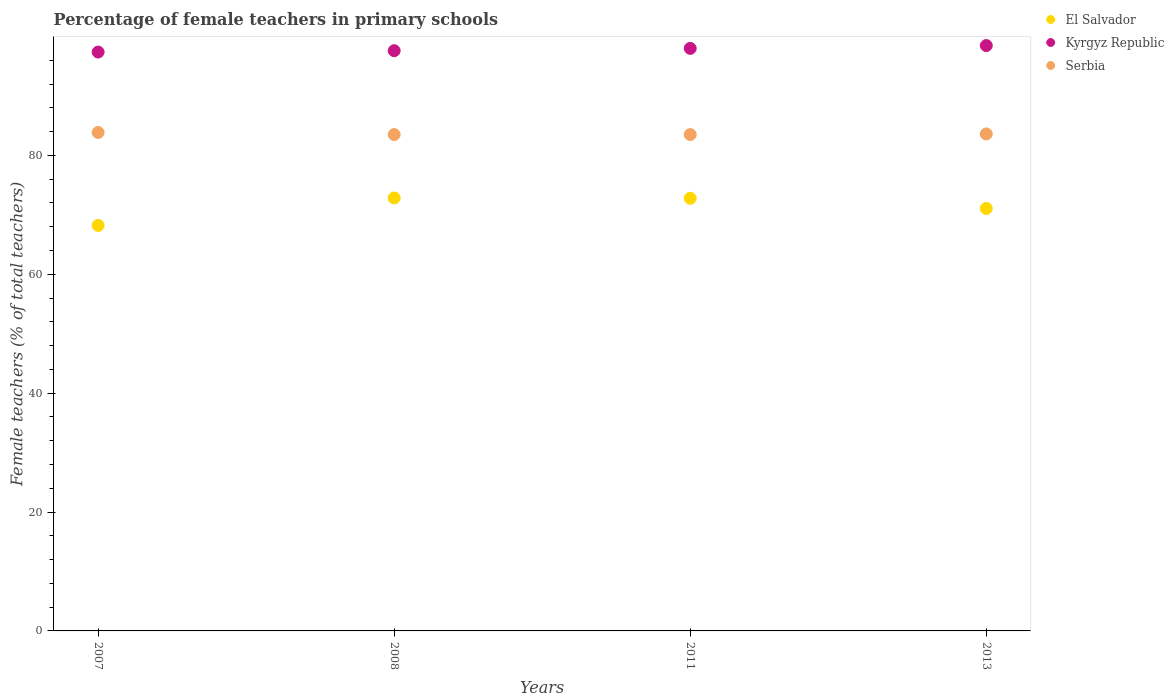What is the percentage of female teachers in Serbia in 2008?
Provide a succinct answer. 83.51. Across all years, what is the maximum percentage of female teachers in El Salvador?
Offer a terse response. 72.84. Across all years, what is the minimum percentage of female teachers in Serbia?
Provide a short and direct response. 83.5. In which year was the percentage of female teachers in Kyrgyz Republic maximum?
Make the answer very short. 2013. What is the total percentage of female teachers in El Salvador in the graph?
Make the answer very short. 284.91. What is the difference between the percentage of female teachers in Serbia in 2007 and that in 2013?
Ensure brevity in your answer.  0.24. What is the difference between the percentage of female teachers in El Salvador in 2013 and the percentage of female teachers in Serbia in 2007?
Keep it short and to the point. -12.78. What is the average percentage of female teachers in El Salvador per year?
Make the answer very short. 71.23. In the year 2007, what is the difference between the percentage of female teachers in Serbia and percentage of female teachers in El Salvador?
Offer a terse response. 15.63. In how many years, is the percentage of female teachers in El Salvador greater than 4 %?
Provide a succinct answer. 4. What is the ratio of the percentage of female teachers in El Salvador in 2007 to that in 2013?
Your answer should be very brief. 0.96. Is the difference between the percentage of female teachers in Serbia in 2011 and 2013 greater than the difference between the percentage of female teachers in El Salvador in 2011 and 2013?
Provide a short and direct response. No. What is the difference between the highest and the second highest percentage of female teachers in Serbia?
Your answer should be very brief. 0.24. What is the difference between the highest and the lowest percentage of female teachers in Serbia?
Provide a succinct answer. 0.35. In how many years, is the percentage of female teachers in Kyrgyz Republic greater than the average percentage of female teachers in Kyrgyz Republic taken over all years?
Offer a very short reply. 2. Is the sum of the percentage of female teachers in Serbia in 2007 and 2011 greater than the maximum percentage of female teachers in Kyrgyz Republic across all years?
Give a very brief answer. Yes. Is it the case that in every year, the sum of the percentage of female teachers in Serbia and percentage of female teachers in Kyrgyz Republic  is greater than the percentage of female teachers in El Salvador?
Your answer should be very brief. Yes. Is the percentage of female teachers in Serbia strictly less than the percentage of female teachers in El Salvador over the years?
Offer a very short reply. No. How many dotlines are there?
Ensure brevity in your answer.  3. What is the difference between two consecutive major ticks on the Y-axis?
Offer a very short reply. 20. Does the graph contain any zero values?
Your answer should be compact. No. How many legend labels are there?
Provide a succinct answer. 3. What is the title of the graph?
Give a very brief answer. Percentage of female teachers in primary schools. Does "Egypt, Arab Rep." appear as one of the legend labels in the graph?
Your answer should be very brief. No. What is the label or title of the Y-axis?
Ensure brevity in your answer.  Female teachers (% of total teachers). What is the Female teachers (% of total teachers) of El Salvador in 2007?
Provide a succinct answer. 68.22. What is the Female teachers (% of total teachers) of Kyrgyz Republic in 2007?
Offer a very short reply. 97.38. What is the Female teachers (% of total teachers) in Serbia in 2007?
Make the answer very short. 83.85. What is the Female teachers (% of total teachers) of El Salvador in 2008?
Make the answer very short. 72.84. What is the Female teachers (% of total teachers) of Kyrgyz Republic in 2008?
Offer a very short reply. 97.62. What is the Female teachers (% of total teachers) in Serbia in 2008?
Provide a short and direct response. 83.51. What is the Female teachers (% of total teachers) of El Salvador in 2011?
Provide a succinct answer. 72.78. What is the Female teachers (% of total teachers) in Kyrgyz Republic in 2011?
Ensure brevity in your answer.  98.01. What is the Female teachers (% of total teachers) of Serbia in 2011?
Offer a very short reply. 83.5. What is the Female teachers (% of total teachers) of El Salvador in 2013?
Provide a succinct answer. 71.07. What is the Female teachers (% of total teachers) in Kyrgyz Republic in 2013?
Your answer should be compact. 98.48. What is the Female teachers (% of total teachers) in Serbia in 2013?
Keep it short and to the point. 83.61. Across all years, what is the maximum Female teachers (% of total teachers) of El Salvador?
Your response must be concise. 72.84. Across all years, what is the maximum Female teachers (% of total teachers) of Kyrgyz Republic?
Your answer should be compact. 98.48. Across all years, what is the maximum Female teachers (% of total teachers) of Serbia?
Ensure brevity in your answer.  83.85. Across all years, what is the minimum Female teachers (% of total teachers) in El Salvador?
Ensure brevity in your answer.  68.22. Across all years, what is the minimum Female teachers (% of total teachers) in Kyrgyz Republic?
Offer a terse response. 97.38. Across all years, what is the minimum Female teachers (% of total teachers) of Serbia?
Keep it short and to the point. 83.5. What is the total Female teachers (% of total teachers) of El Salvador in the graph?
Your response must be concise. 284.91. What is the total Female teachers (% of total teachers) of Kyrgyz Republic in the graph?
Your answer should be very brief. 391.48. What is the total Female teachers (% of total teachers) in Serbia in the graph?
Give a very brief answer. 334.48. What is the difference between the Female teachers (% of total teachers) of El Salvador in 2007 and that in 2008?
Give a very brief answer. -4.62. What is the difference between the Female teachers (% of total teachers) of Kyrgyz Republic in 2007 and that in 2008?
Your answer should be compact. -0.23. What is the difference between the Female teachers (% of total teachers) of Serbia in 2007 and that in 2008?
Offer a terse response. 0.35. What is the difference between the Female teachers (% of total teachers) of El Salvador in 2007 and that in 2011?
Offer a very short reply. -4.56. What is the difference between the Female teachers (% of total teachers) in Kyrgyz Republic in 2007 and that in 2011?
Offer a very short reply. -0.62. What is the difference between the Female teachers (% of total teachers) in Serbia in 2007 and that in 2011?
Provide a short and direct response. 0.35. What is the difference between the Female teachers (% of total teachers) in El Salvador in 2007 and that in 2013?
Ensure brevity in your answer.  -2.85. What is the difference between the Female teachers (% of total teachers) of Kyrgyz Republic in 2007 and that in 2013?
Ensure brevity in your answer.  -1.09. What is the difference between the Female teachers (% of total teachers) of Serbia in 2007 and that in 2013?
Keep it short and to the point. 0.24. What is the difference between the Female teachers (% of total teachers) in El Salvador in 2008 and that in 2011?
Keep it short and to the point. 0.06. What is the difference between the Female teachers (% of total teachers) in Kyrgyz Republic in 2008 and that in 2011?
Your response must be concise. -0.39. What is the difference between the Female teachers (% of total teachers) in Serbia in 2008 and that in 2011?
Offer a terse response. 0. What is the difference between the Female teachers (% of total teachers) in El Salvador in 2008 and that in 2013?
Provide a succinct answer. 1.77. What is the difference between the Female teachers (% of total teachers) of Kyrgyz Republic in 2008 and that in 2013?
Offer a terse response. -0.86. What is the difference between the Female teachers (% of total teachers) in Serbia in 2008 and that in 2013?
Ensure brevity in your answer.  -0.1. What is the difference between the Female teachers (% of total teachers) in El Salvador in 2011 and that in 2013?
Give a very brief answer. 1.71. What is the difference between the Female teachers (% of total teachers) of Kyrgyz Republic in 2011 and that in 2013?
Offer a very short reply. -0.47. What is the difference between the Female teachers (% of total teachers) in Serbia in 2011 and that in 2013?
Give a very brief answer. -0.11. What is the difference between the Female teachers (% of total teachers) in El Salvador in 2007 and the Female teachers (% of total teachers) in Kyrgyz Republic in 2008?
Provide a succinct answer. -29.4. What is the difference between the Female teachers (% of total teachers) of El Salvador in 2007 and the Female teachers (% of total teachers) of Serbia in 2008?
Your answer should be compact. -15.29. What is the difference between the Female teachers (% of total teachers) of Kyrgyz Republic in 2007 and the Female teachers (% of total teachers) of Serbia in 2008?
Offer a terse response. 13.88. What is the difference between the Female teachers (% of total teachers) in El Salvador in 2007 and the Female teachers (% of total teachers) in Kyrgyz Republic in 2011?
Offer a terse response. -29.79. What is the difference between the Female teachers (% of total teachers) of El Salvador in 2007 and the Female teachers (% of total teachers) of Serbia in 2011?
Offer a very short reply. -15.29. What is the difference between the Female teachers (% of total teachers) of Kyrgyz Republic in 2007 and the Female teachers (% of total teachers) of Serbia in 2011?
Provide a succinct answer. 13.88. What is the difference between the Female teachers (% of total teachers) in El Salvador in 2007 and the Female teachers (% of total teachers) in Kyrgyz Republic in 2013?
Give a very brief answer. -30.26. What is the difference between the Female teachers (% of total teachers) in El Salvador in 2007 and the Female teachers (% of total teachers) in Serbia in 2013?
Offer a terse response. -15.39. What is the difference between the Female teachers (% of total teachers) in Kyrgyz Republic in 2007 and the Female teachers (% of total teachers) in Serbia in 2013?
Your answer should be compact. 13.77. What is the difference between the Female teachers (% of total teachers) of El Salvador in 2008 and the Female teachers (% of total teachers) of Kyrgyz Republic in 2011?
Provide a short and direct response. -25.17. What is the difference between the Female teachers (% of total teachers) of El Salvador in 2008 and the Female teachers (% of total teachers) of Serbia in 2011?
Offer a very short reply. -10.67. What is the difference between the Female teachers (% of total teachers) in Kyrgyz Republic in 2008 and the Female teachers (% of total teachers) in Serbia in 2011?
Make the answer very short. 14.11. What is the difference between the Female teachers (% of total teachers) in El Salvador in 2008 and the Female teachers (% of total teachers) in Kyrgyz Republic in 2013?
Your response must be concise. -25.64. What is the difference between the Female teachers (% of total teachers) of El Salvador in 2008 and the Female teachers (% of total teachers) of Serbia in 2013?
Your response must be concise. -10.77. What is the difference between the Female teachers (% of total teachers) in Kyrgyz Republic in 2008 and the Female teachers (% of total teachers) in Serbia in 2013?
Make the answer very short. 14. What is the difference between the Female teachers (% of total teachers) in El Salvador in 2011 and the Female teachers (% of total teachers) in Kyrgyz Republic in 2013?
Your response must be concise. -25.7. What is the difference between the Female teachers (% of total teachers) of El Salvador in 2011 and the Female teachers (% of total teachers) of Serbia in 2013?
Provide a short and direct response. -10.83. What is the difference between the Female teachers (% of total teachers) of Kyrgyz Republic in 2011 and the Female teachers (% of total teachers) of Serbia in 2013?
Provide a short and direct response. 14.39. What is the average Female teachers (% of total teachers) in El Salvador per year?
Make the answer very short. 71.23. What is the average Female teachers (% of total teachers) of Kyrgyz Republic per year?
Your answer should be very brief. 97.87. What is the average Female teachers (% of total teachers) in Serbia per year?
Keep it short and to the point. 83.62. In the year 2007, what is the difference between the Female teachers (% of total teachers) of El Salvador and Female teachers (% of total teachers) of Kyrgyz Republic?
Offer a very short reply. -29.17. In the year 2007, what is the difference between the Female teachers (% of total teachers) of El Salvador and Female teachers (% of total teachers) of Serbia?
Your answer should be compact. -15.63. In the year 2007, what is the difference between the Female teachers (% of total teachers) in Kyrgyz Republic and Female teachers (% of total teachers) in Serbia?
Make the answer very short. 13.53. In the year 2008, what is the difference between the Female teachers (% of total teachers) of El Salvador and Female teachers (% of total teachers) of Kyrgyz Republic?
Your response must be concise. -24.78. In the year 2008, what is the difference between the Female teachers (% of total teachers) of El Salvador and Female teachers (% of total teachers) of Serbia?
Give a very brief answer. -10.67. In the year 2008, what is the difference between the Female teachers (% of total teachers) in Kyrgyz Republic and Female teachers (% of total teachers) in Serbia?
Offer a terse response. 14.11. In the year 2011, what is the difference between the Female teachers (% of total teachers) of El Salvador and Female teachers (% of total teachers) of Kyrgyz Republic?
Provide a short and direct response. -25.22. In the year 2011, what is the difference between the Female teachers (% of total teachers) in El Salvador and Female teachers (% of total teachers) in Serbia?
Keep it short and to the point. -10.72. In the year 2011, what is the difference between the Female teachers (% of total teachers) in Kyrgyz Republic and Female teachers (% of total teachers) in Serbia?
Provide a short and direct response. 14.5. In the year 2013, what is the difference between the Female teachers (% of total teachers) of El Salvador and Female teachers (% of total teachers) of Kyrgyz Republic?
Your response must be concise. -27.4. In the year 2013, what is the difference between the Female teachers (% of total teachers) in El Salvador and Female teachers (% of total teachers) in Serbia?
Offer a terse response. -12.54. In the year 2013, what is the difference between the Female teachers (% of total teachers) of Kyrgyz Republic and Female teachers (% of total teachers) of Serbia?
Your answer should be very brief. 14.87. What is the ratio of the Female teachers (% of total teachers) in El Salvador in 2007 to that in 2008?
Your answer should be very brief. 0.94. What is the ratio of the Female teachers (% of total teachers) of Serbia in 2007 to that in 2008?
Your answer should be compact. 1. What is the ratio of the Female teachers (% of total teachers) of El Salvador in 2007 to that in 2011?
Ensure brevity in your answer.  0.94. What is the ratio of the Female teachers (% of total teachers) of Serbia in 2007 to that in 2011?
Provide a short and direct response. 1. What is the ratio of the Female teachers (% of total teachers) in El Salvador in 2007 to that in 2013?
Your response must be concise. 0.96. What is the ratio of the Female teachers (% of total teachers) in Kyrgyz Republic in 2007 to that in 2013?
Provide a short and direct response. 0.99. What is the ratio of the Female teachers (% of total teachers) in Serbia in 2007 to that in 2013?
Offer a terse response. 1. What is the ratio of the Female teachers (% of total teachers) of El Salvador in 2008 to that in 2011?
Give a very brief answer. 1. What is the ratio of the Female teachers (% of total teachers) of Serbia in 2008 to that in 2011?
Your answer should be compact. 1. What is the ratio of the Female teachers (% of total teachers) in El Salvador in 2008 to that in 2013?
Make the answer very short. 1.02. What is the ratio of the Female teachers (% of total teachers) of Kyrgyz Republic in 2008 to that in 2013?
Your response must be concise. 0.99. What is the ratio of the Female teachers (% of total teachers) of El Salvador in 2011 to that in 2013?
Your answer should be very brief. 1.02. What is the difference between the highest and the second highest Female teachers (% of total teachers) of El Salvador?
Your answer should be very brief. 0.06. What is the difference between the highest and the second highest Female teachers (% of total teachers) in Kyrgyz Republic?
Your answer should be compact. 0.47. What is the difference between the highest and the second highest Female teachers (% of total teachers) in Serbia?
Provide a short and direct response. 0.24. What is the difference between the highest and the lowest Female teachers (% of total teachers) in El Salvador?
Offer a very short reply. 4.62. What is the difference between the highest and the lowest Female teachers (% of total teachers) of Kyrgyz Republic?
Provide a succinct answer. 1.09. What is the difference between the highest and the lowest Female teachers (% of total teachers) of Serbia?
Your answer should be compact. 0.35. 